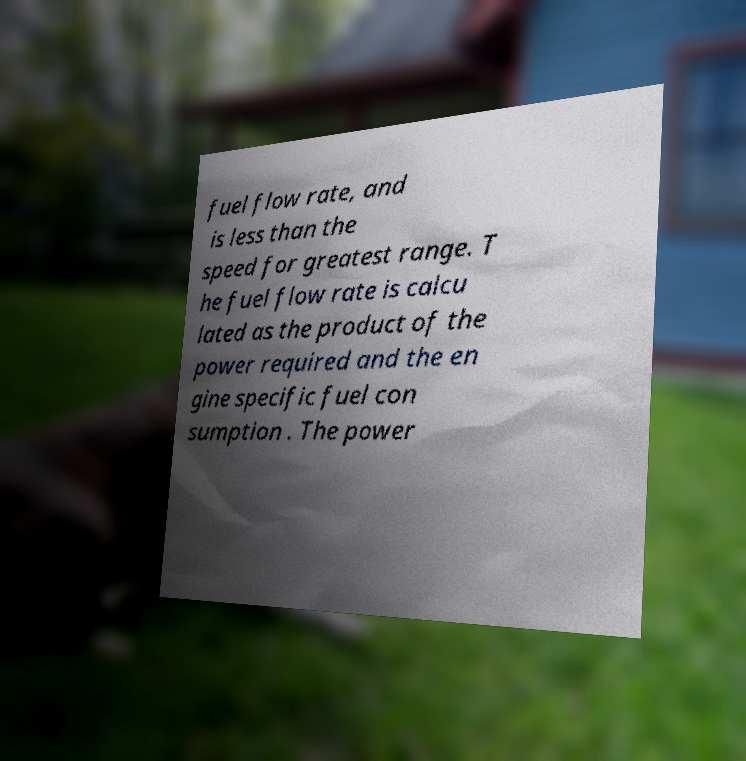For documentation purposes, I need the text within this image transcribed. Could you provide that? fuel flow rate, and is less than the speed for greatest range. T he fuel flow rate is calcu lated as the product of the power required and the en gine specific fuel con sumption . The power 